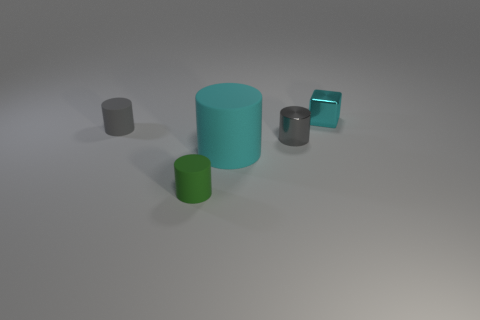Is there any other thing that is the same shape as the tiny cyan object?
Give a very brief answer. No. Are there any other things that have the same size as the cyan rubber object?
Your response must be concise. No. What number of objects are either tiny shiny things that are behind the small shiny cylinder or cylinders on the left side of the green rubber cylinder?
Offer a terse response. 2. How many things are small brown matte spheres or cyan objects in front of the shiny block?
Provide a short and direct response. 1. How big is the cyan object in front of the cylinder that is behind the small shiny thing that is to the left of the cyan shiny block?
Keep it short and to the point. Large. What is the material of the cyan thing that is the same size as the gray rubber cylinder?
Your response must be concise. Metal. Are there any other cyan cubes of the same size as the shiny block?
Your answer should be compact. No. Do the shiny object in front of the cyan shiny object and the small green cylinder have the same size?
Provide a succinct answer. Yes. The tiny object that is to the left of the gray metallic thing and on the right side of the gray matte thing has what shape?
Provide a succinct answer. Cylinder. Is the number of small matte cylinders on the right side of the tiny gray rubber cylinder greater than the number of matte objects?
Give a very brief answer. No. 